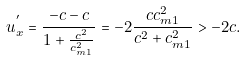<formula> <loc_0><loc_0><loc_500><loc_500>u _ { x } ^ { ^ { \prime } } = \frac { - c - c } { 1 + \frac { c ^ { 2 } } { c _ { m 1 } ^ { 2 } } } = - 2 \frac { c c _ { m 1 } ^ { 2 } } { c ^ { 2 } + c _ { m 1 } ^ { 2 } } > - 2 c .</formula> 